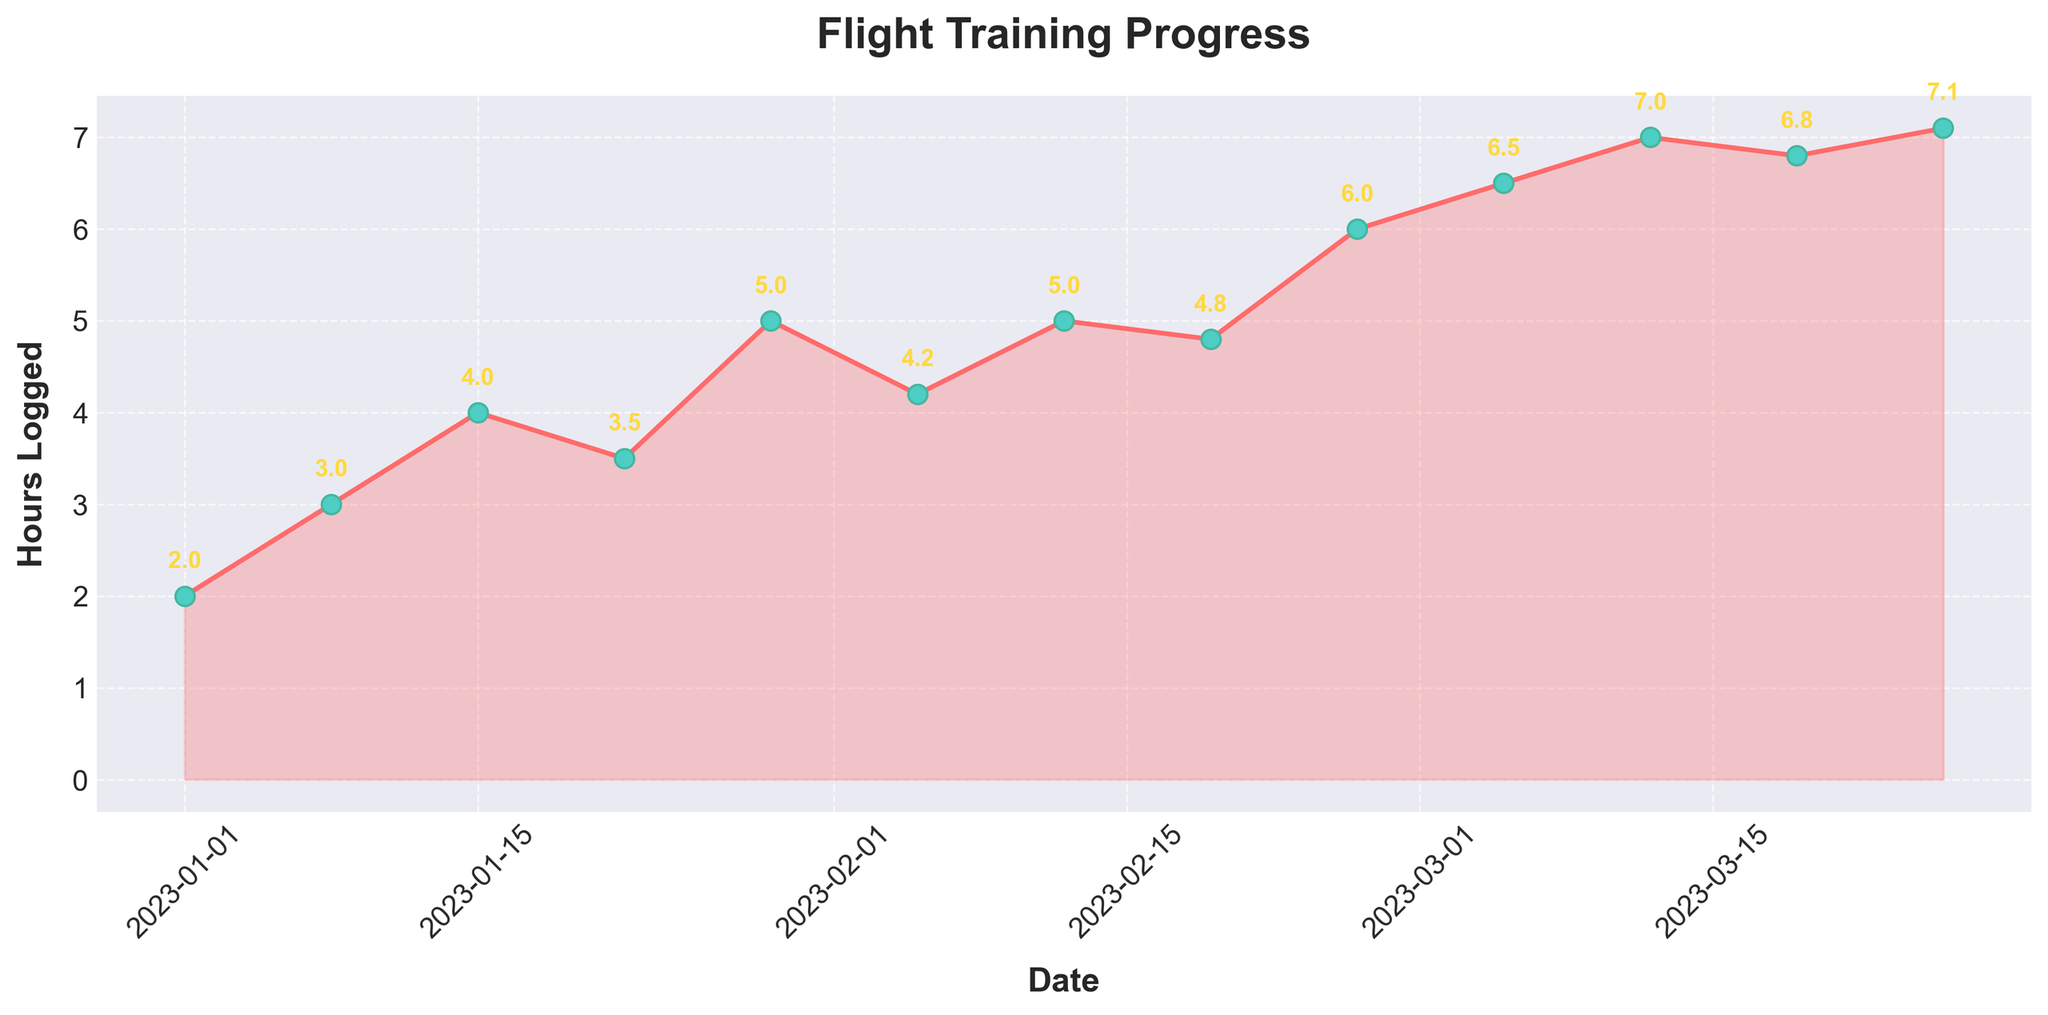What's the title of the figure? The title of the figure is centered at the top of the plot area and can be read directly.
Answer: Flight Training Progress How many data points are shown in the figure? To determine the number of data points, count all the markers on the time series plot.
Answer: 13 What's the highest number of hours logged in a single week? To identify this, look for the highest point on the plot and read the y-axis value corresponding to that point.
Answer: 7.1 What is the average number of hours logged per week? Sum all the hours logged and divide by the number of data points: (2 + 3 + 4 + 3.5 + 5 + 4.2 + 5 + 4.8 + 6 + 6.5 + 7 + 6.8 + 7.1) / 13 = 64.9 / 13
Answer: 4.99 Which week shows the greatest increase in hours logged compared to the previous week? Calculate the difference between consecutive weeks and identify the week with the largest increase. The greatest increase is between 2023-02-26 (6) and 2023-03-05 (6.5), which is an increase of 0.5.
Answer: 2023-03-05 Which date corresponds to the first time more than 6 hours were logged? Look for the first point on the plot where the hours are above 6 and note the corresponding date.
Answer: 2023-03-05 Is there a trend or pattern in the hours logged over time? Observe the overall shape and direction of the line to see if it generally goes up, down, or remains stable over time. The hours logged exhibit a general upward trend.
Answer: Upward trend Between which two consecutive dates is the smallest drop in hours logged? Calculate the difference in hours logged between each pair of consecutive dates and note the smallest drop. The smallest drop is between 2023-02-19 (4.8) and 2023-02-26 (6), which is actually an increase, making it a zero drop.
Answer: None, there was an increase How many times was more than 6 hours logged in a week? Count the number of data points that are above the 6-hour mark.
Answer: 4 